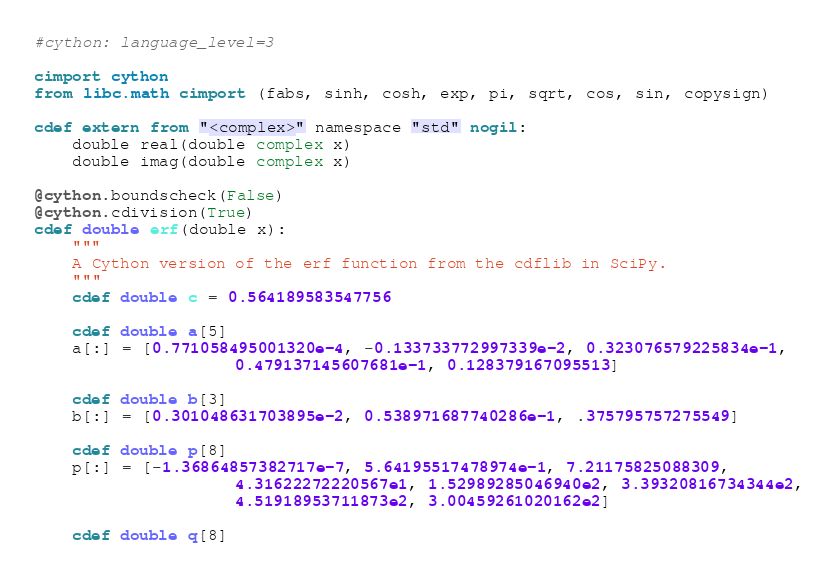Convert code to text. <code><loc_0><loc_0><loc_500><loc_500><_Cython_>#cython: language_level=3

cimport cython
from libc.math cimport (fabs, sinh, cosh, exp, pi, sqrt, cos, sin, copysign)

cdef extern from "<complex>" namespace "std" nogil:
    double real(double complex x)
    double imag(double complex x)

@cython.boundscheck(False)
@cython.cdivision(True)
cdef double erf(double x):
    """
    A Cython version of the erf function from the cdflib in SciPy.
    """
    cdef double c = 0.564189583547756

    cdef double a[5]
    a[:] = [0.771058495001320e-4, -0.133733772997339e-2, 0.323076579225834e-1,
                     0.479137145607681e-1, 0.128379167095513]

    cdef double b[3]
    b[:] = [0.301048631703895e-2, 0.538971687740286e-1, .375795757275549]

    cdef double p[8]
    p[:] = [-1.36864857382717e-7, 5.64195517478974e-1, 7.21175825088309,
                     4.31622272220567e1, 1.52989285046940e2, 3.39320816734344e2,
                     4.51918953711873e2, 3.00459261020162e2]

    cdef double q[8]</code> 